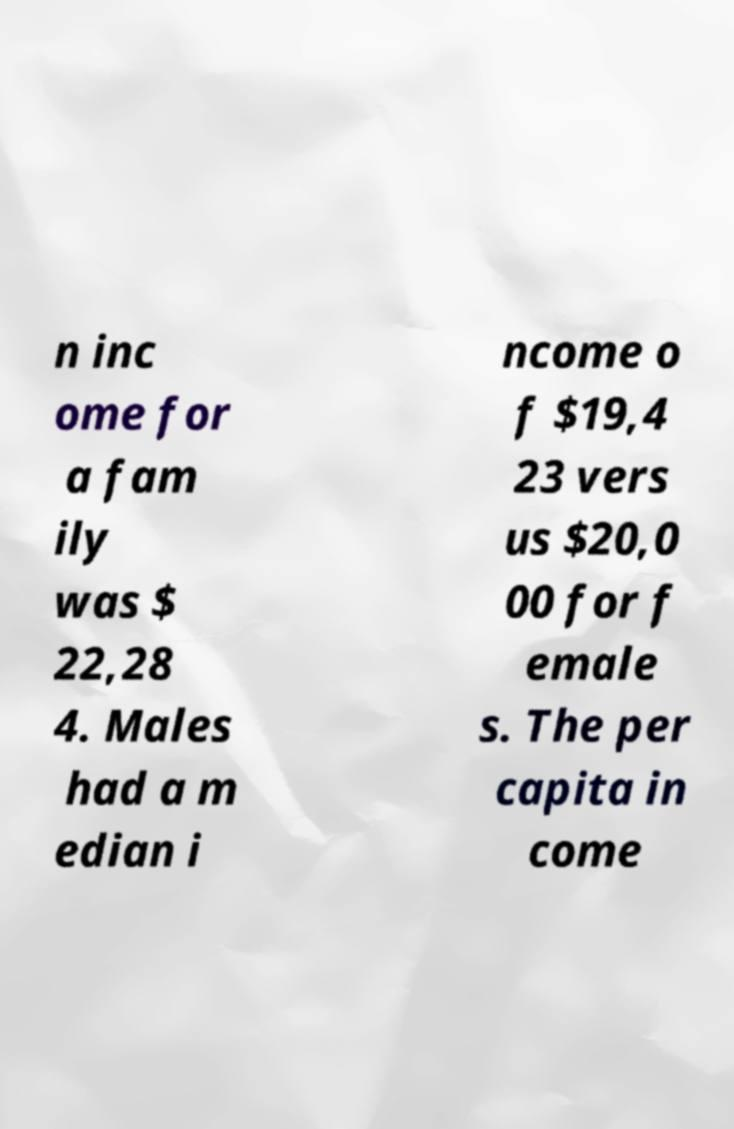Could you extract and type out the text from this image? n inc ome for a fam ily was $ 22,28 4. Males had a m edian i ncome o f $19,4 23 vers us $20,0 00 for f emale s. The per capita in come 